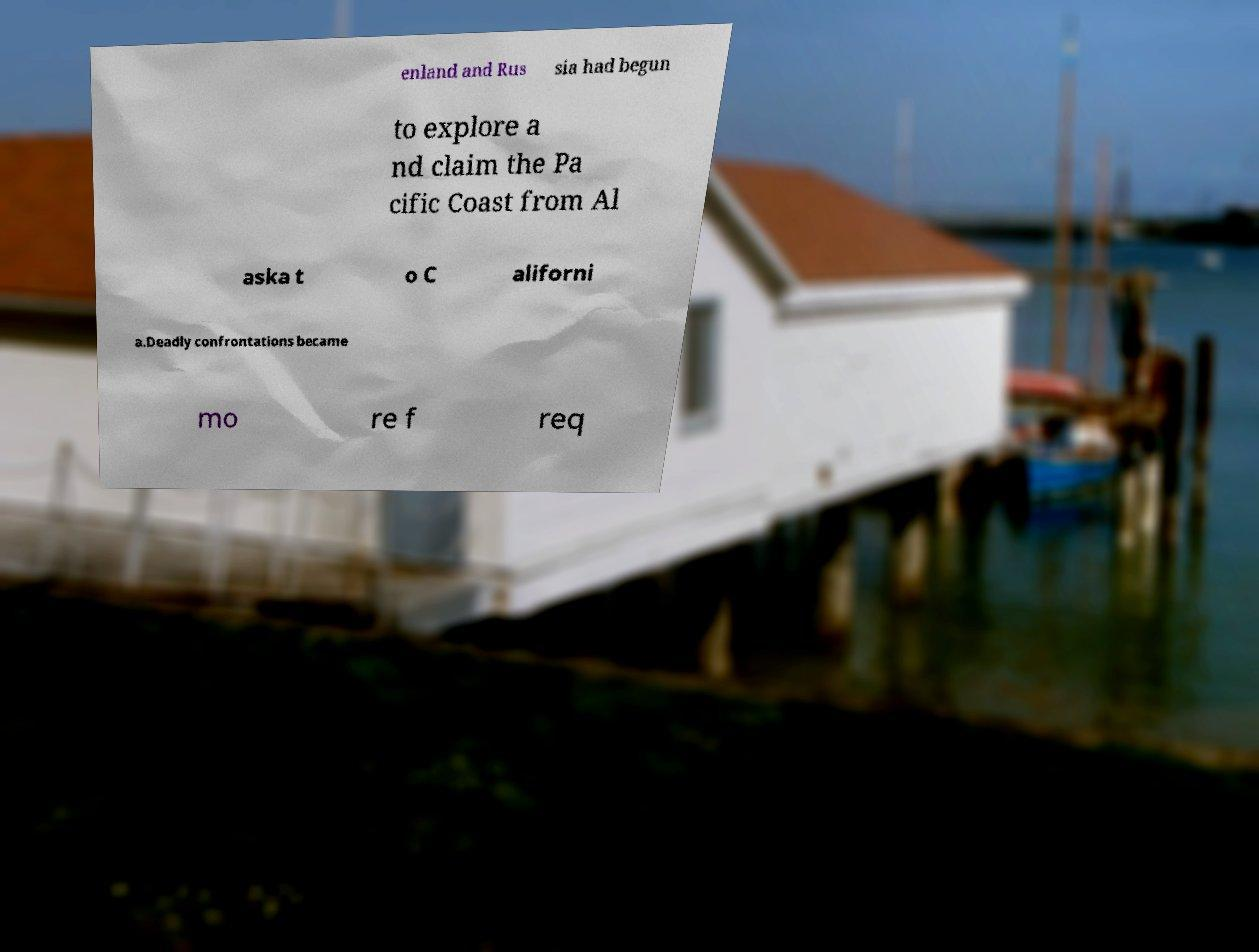What messages or text are displayed in this image? I need them in a readable, typed format. enland and Rus sia had begun to explore a nd claim the Pa cific Coast from Al aska t o C aliforni a.Deadly confrontations became mo re f req 